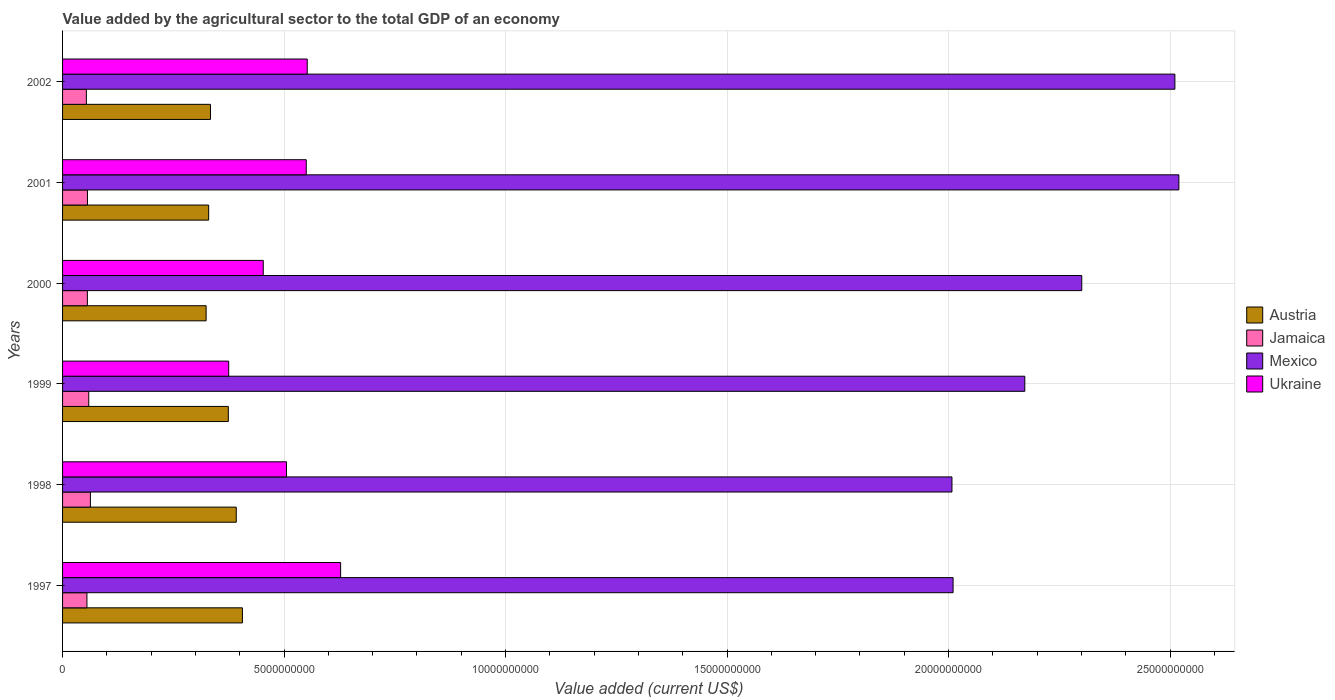How many different coloured bars are there?
Your answer should be compact. 4. How many groups of bars are there?
Your response must be concise. 6. How many bars are there on the 3rd tick from the bottom?
Your answer should be very brief. 4. What is the value added by the agricultural sector to the total GDP in Ukraine in 1997?
Give a very brief answer. 6.28e+09. Across all years, what is the maximum value added by the agricultural sector to the total GDP in Jamaica?
Give a very brief answer. 6.28e+08. Across all years, what is the minimum value added by the agricultural sector to the total GDP in Ukraine?
Keep it short and to the point. 3.75e+09. In which year was the value added by the agricultural sector to the total GDP in Jamaica minimum?
Your answer should be compact. 2002. What is the total value added by the agricultural sector to the total GDP in Jamaica in the graph?
Your response must be concise. 3.43e+09. What is the difference between the value added by the agricultural sector to the total GDP in Jamaica in 1999 and that in 2000?
Your response must be concise. 3.12e+07. What is the difference between the value added by the agricultural sector to the total GDP in Austria in 1999 and the value added by the agricultural sector to the total GDP in Jamaica in 2002?
Offer a very short reply. 3.20e+09. What is the average value added by the agricultural sector to the total GDP in Ukraine per year?
Make the answer very short. 5.11e+09. In the year 2002, what is the difference between the value added by the agricultural sector to the total GDP in Austria and value added by the agricultural sector to the total GDP in Ukraine?
Keep it short and to the point. -2.18e+09. In how many years, is the value added by the agricultural sector to the total GDP in Jamaica greater than 19000000000 US$?
Provide a short and direct response. 0. What is the ratio of the value added by the agricultural sector to the total GDP in Jamaica in 1998 to that in 2002?
Your answer should be compact. 1.17. What is the difference between the highest and the second highest value added by the agricultural sector to the total GDP in Ukraine?
Your answer should be very brief. 7.54e+08. What is the difference between the highest and the lowest value added by the agricultural sector to the total GDP in Ukraine?
Ensure brevity in your answer.  2.53e+09. In how many years, is the value added by the agricultural sector to the total GDP in Mexico greater than the average value added by the agricultural sector to the total GDP in Mexico taken over all years?
Make the answer very short. 3. What does the 3rd bar from the top in 2002 represents?
Provide a short and direct response. Jamaica. What does the 4th bar from the bottom in 1997 represents?
Your response must be concise. Ukraine. How many bars are there?
Provide a short and direct response. 24. Are the values on the major ticks of X-axis written in scientific E-notation?
Provide a succinct answer. No. Where does the legend appear in the graph?
Ensure brevity in your answer.  Center right. What is the title of the graph?
Keep it short and to the point. Value added by the agricultural sector to the total GDP of an economy. What is the label or title of the X-axis?
Make the answer very short. Value added (current US$). What is the Value added (current US$) of Austria in 1997?
Offer a very short reply. 4.06e+09. What is the Value added (current US$) of Jamaica in 1997?
Provide a short and direct response. 5.50e+08. What is the Value added (current US$) of Mexico in 1997?
Ensure brevity in your answer.  2.01e+1. What is the Value added (current US$) in Ukraine in 1997?
Your answer should be compact. 6.28e+09. What is the Value added (current US$) in Austria in 1998?
Your answer should be compact. 3.92e+09. What is the Value added (current US$) in Jamaica in 1998?
Your answer should be very brief. 6.28e+08. What is the Value added (current US$) of Mexico in 1998?
Offer a very short reply. 2.01e+1. What is the Value added (current US$) in Ukraine in 1998?
Offer a very short reply. 5.05e+09. What is the Value added (current US$) of Austria in 1999?
Offer a terse response. 3.74e+09. What is the Value added (current US$) of Jamaica in 1999?
Provide a succinct answer. 5.91e+08. What is the Value added (current US$) of Mexico in 1999?
Ensure brevity in your answer.  2.17e+1. What is the Value added (current US$) in Ukraine in 1999?
Ensure brevity in your answer.  3.75e+09. What is the Value added (current US$) in Austria in 2000?
Provide a short and direct response. 3.24e+09. What is the Value added (current US$) of Jamaica in 2000?
Provide a short and direct response. 5.60e+08. What is the Value added (current US$) in Mexico in 2000?
Your answer should be compact. 2.30e+1. What is the Value added (current US$) in Ukraine in 2000?
Offer a very short reply. 4.53e+09. What is the Value added (current US$) in Austria in 2001?
Offer a terse response. 3.30e+09. What is the Value added (current US$) of Jamaica in 2001?
Provide a succinct answer. 5.62e+08. What is the Value added (current US$) in Mexico in 2001?
Make the answer very short. 2.52e+1. What is the Value added (current US$) in Ukraine in 2001?
Give a very brief answer. 5.50e+09. What is the Value added (current US$) of Austria in 2002?
Keep it short and to the point. 3.34e+09. What is the Value added (current US$) in Jamaica in 2002?
Your answer should be very brief. 5.37e+08. What is the Value added (current US$) in Mexico in 2002?
Your answer should be compact. 2.51e+1. What is the Value added (current US$) in Ukraine in 2002?
Your answer should be very brief. 5.52e+09. Across all years, what is the maximum Value added (current US$) in Austria?
Provide a short and direct response. 4.06e+09. Across all years, what is the maximum Value added (current US$) of Jamaica?
Your answer should be very brief. 6.28e+08. Across all years, what is the maximum Value added (current US$) in Mexico?
Your answer should be compact. 2.52e+1. Across all years, what is the maximum Value added (current US$) in Ukraine?
Give a very brief answer. 6.28e+09. Across all years, what is the minimum Value added (current US$) in Austria?
Your answer should be very brief. 3.24e+09. Across all years, what is the minimum Value added (current US$) of Jamaica?
Ensure brevity in your answer.  5.37e+08. Across all years, what is the minimum Value added (current US$) of Mexico?
Provide a succinct answer. 2.01e+1. Across all years, what is the minimum Value added (current US$) of Ukraine?
Your response must be concise. 3.75e+09. What is the total Value added (current US$) in Austria in the graph?
Offer a very short reply. 2.16e+1. What is the total Value added (current US$) of Jamaica in the graph?
Offer a terse response. 3.43e+09. What is the total Value added (current US$) in Mexico in the graph?
Keep it short and to the point. 1.35e+11. What is the total Value added (current US$) of Ukraine in the graph?
Give a very brief answer. 3.06e+1. What is the difference between the Value added (current US$) in Austria in 1997 and that in 1998?
Ensure brevity in your answer.  1.39e+08. What is the difference between the Value added (current US$) in Jamaica in 1997 and that in 1998?
Give a very brief answer. -7.83e+07. What is the difference between the Value added (current US$) in Mexico in 1997 and that in 1998?
Make the answer very short. 2.55e+07. What is the difference between the Value added (current US$) in Ukraine in 1997 and that in 1998?
Your answer should be very brief. 1.22e+09. What is the difference between the Value added (current US$) of Austria in 1997 and that in 1999?
Give a very brief answer. 3.18e+08. What is the difference between the Value added (current US$) in Jamaica in 1997 and that in 1999?
Give a very brief answer. -4.11e+07. What is the difference between the Value added (current US$) in Mexico in 1997 and that in 1999?
Keep it short and to the point. -1.62e+09. What is the difference between the Value added (current US$) of Ukraine in 1997 and that in 1999?
Your response must be concise. 2.53e+09. What is the difference between the Value added (current US$) in Austria in 1997 and that in 2000?
Your answer should be compact. 8.19e+08. What is the difference between the Value added (current US$) of Jamaica in 1997 and that in 2000?
Provide a succinct answer. -9.88e+06. What is the difference between the Value added (current US$) in Mexico in 1997 and that in 2000?
Provide a short and direct response. -2.90e+09. What is the difference between the Value added (current US$) in Ukraine in 1997 and that in 2000?
Your response must be concise. 1.75e+09. What is the difference between the Value added (current US$) of Austria in 1997 and that in 2001?
Offer a terse response. 7.62e+08. What is the difference between the Value added (current US$) of Jamaica in 1997 and that in 2001?
Your response must be concise. -1.16e+07. What is the difference between the Value added (current US$) in Mexico in 1997 and that in 2001?
Ensure brevity in your answer.  -5.10e+09. What is the difference between the Value added (current US$) of Ukraine in 1997 and that in 2001?
Give a very brief answer. 7.76e+08. What is the difference between the Value added (current US$) in Austria in 1997 and that in 2002?
Provide a short and direct response. 7.21e+08. What is the difference between the Value added (current US$) in Jamaica in 1997 and that in 2002?
Your response must be concise. 1.27e+07. What is the difference between the Value added (current US$) in Mexico in 1997 and that in 2002?
Make the answer very short. -5.01e+09. What is the difference between the Value added (current US$) in Ukraine in 1997 and that in 2002?
Keep it short and to the point. 7.54e+08. What is the difference between the Value added (current US$) in Austria in 1998 and that in 1999?
Ensure brevity in your answer.  1.79e+08. What is the difference between the Value added (current US$) in Jamaica in 1998 and that in 1999?
Provide a short and direct response. 3.72e+07. What is the difference between the Value added (current US$) in Mexico in 1998 and that in 1999?
Make the answer very short. -1.64e+09. What is the difference between the Value added (current US$) in Ukraine in 1998 and that in 1999?
Ensure brevity in your answer.  1.30e+09. What is the difference between the Value added (current US$) of Austria in 1998 and that in 2000?
Ensure brevity in your answer.  6.80e+08. What is the difference between the Value added (current US$) of Jamaica in 1998 and that in 2000?
Your response must be concise. 6.84e+07. What is the difference between the Value added (current US$) of Mexico in 1998 and that in 2000?
Give a very brief answer. -2.93e+09. What is the difference between the Value added (current US$) in Ukraine in 1998 and that in 2000?
Your answer should be compact. 5.25e+08. What is the difference between the Value added (current US$) of Austria in 1998 and that in 2001?
Ensure brevity in your answer.  6.22e+08. What is the difference between the Value added (current US$) in Jamaica in 1998 and that in 2001?
Offer a terse response. 6.67e+07. What is the difference between the Value added (current US$) of Mexico in 1998 and that in 2001?
Make the answer very short. -5.12e+09. What is the difference between the Value added (current US$) in Ukraine in 1998 and that in 2001?
Provide a short and direct response. -4.46e+08. What is the difference between the Value added (current US$) in Austria in 1998 and that in 2002?
Keep it short and to the point. 5.81e+08. What is the difference between the Value added (current US$) of Jamaica in 1998 and that in 2002?
Your response must be concise. 9.09e+07. What is the difference between the Value added (current US$) of Mexico in 1998 and that in 2002?
Provide a succinct answer. -5.03e+09. What is the difference between the Value added (current US$) in Ukraine in 1998 and that in 2002?
Keep it short and to the point. -4.68e+08. What is the difference between the Value added (current US$) of Austria in 1999 and that in 2000?
Offer a terse response. 5.01e+08. What is the difference between the Value added (current US$) in Jamaica in 1999 and that in 2000?
Provide a succinct answer. 3.12e+07. What is the difference between the Value added (current US$) in Mexico in 1999 and that in 2000?
Your response must be concise. -1.29e+09. What is the difference between the Value added (current US$) in Ukraine in 1999 and that in 2000?
Give a very brief answer. -7.80e+08. What is the difference between the Value added (current US$) of Austria in 1999 and that in 2001?
Your answer should be compact. 4.44e+08. What is the difference between the Value added (current US$) of Jamaica in 1999 and that in 2001?
Give a very brief answer. 2.95e+07. What is the difference between the Value added (current US$) of Mexico in 1999 and that in 2001?
Provide a short and direct response. -3.48e+09. What is the difference between the Value added (current US$) of Ukraine in 1999 and that in 2001?
Provide a succinct answer. -1.75e+09. What is the difference between the Value added (current US$) of Austria in 1999 and that in 2002?
Keep it short and to the point. 4.03e+08. What is the difference between the Value added (current US$) in Jamaica in 1999 and that in 2002?
Offer a terse response. 5.38e+07. What is the difference between the Value added (current US$) of Mexico in 1999 and that in 2002?
Ensure brevity in your answer.  -3.39e+09. What is the difference between the Value added (current US$) of Ukraine in 1999 and that in 2002?
Your answer should be very brief. -1.77e+09. What is the difference between the Value added (current US$) of Austria in 2000 and that in 2001?
Provide a short and direct response. -5.76e+07. What is the difference between the Value added (current US$) in Jamaica in 2000 and that in 2001?
Provide a short and direct response. -1.73e+06. What is the difference between the Value added (current US$) of Mexico in 2000 and that in 2001?
Ensure brevity in your answer.  -2.19e+09. What is the difference between the Value added (current US$) in Ukraine in 2000 and that in 2001?
Offer a very short reply. -9.71e+08. What is the difference between the Value added (current US$) of Austria in 2000 and that in 2002?
Provide a succinct answer. -9.85e+07. What is the difference between the Value added (current US$) of Jamaica in 2000 and that in 2002?
Your answer should be compact. 2.26e+07. What is the difference between the Value added (current US$) in Mexico in 2000 and that in 2002?
Your answer should be very brief. -2.10e+09. What is the difference between the Value added (current US$) of Ukraine in 2000 and that in 2002?
Give a very brief answer. -9.93e+08. What is the difference between the Value added (current US$) in Austria in 2001 and that in 2002?
Offer a terse response. -4.09e+07. What is the difference between the Value added (current US$) of Jamaica in 2001 and that in 2002?
Ensure brevity in your answer.  2.43e+07. What is the difference between the Value added (current US$) of Mexico in 2001 and that in 2002?
Your response must be concise. 9.01e+07. What is the difference between the Value added (current US$) of Ukraine in 2001 and that in 2002?
Offer a very short reply. -2.22e+07. What is the difference between the Value added (current US$) of Austria in 1997 and the Value added (current US$) of Jamaica in 1998?
Your answer should be compact. 3.43e+09. What is the difference between the Value added (current US$) of Austria in 1997 and the Value added (current US$) of Mexico in 1998?
Give a very brief answer. -1.60e+1. What is the difference between the Value added (current US$) in Austria in 1997 and the Value added (current US$) in Ukraine in 1998?
Ensure brevity in your answer.  -9.95e+08. What is the difference between the Value added (current US$) in Jamaica in 1997 and the Value added (current US$) in Mexico in 1998?
Your answer should be compact. -1.95e+1. What is the difference between the Value added (current US$) of Jamaica in 1997 and the Value added (current US$) of Ukraine in 1998?
Give a very brief answer. -4.50e+09. What is the difference between the Value added (current US$) of Mexico in 1997 and the Value added (current US$) of Ukraine in 1998?
Offer a very short reply. 1.50e+1. What is the difference between the Value added (current US$) in Austria in 1997 and the Value added (current US$) in Jamaica in 1999?
Give a very brief answer. 3.47e+09. What is the difference between the Value added (current US$) in Austria in 1997 and the Value added (current US$) in Mexico in 1999?
Ensure brevity in your answer.  -1.77e+1. What is the difference between the Value added (current US$) in Austria in 1997 and the Value added (current US$) in Ukraine in 1999?
Provide a succinct answer. 3.10e+08. What is the difference between the Value added (current US$) in Jamaica in 1997 and the Value added (current US$) in Mexico in 1999?
Your answer should be compact. -2.12e+1. What is the difference between the Value added (current US$) in Jamaica in 1997 and the Value added (current US$) in Ukraine in 1999?
Provide a short and direct response. -3.20e+09. What is the difference between the Value added (current US$) of Mexico in 1997 and the Value added (current US$) of Ukraine in 1999?
Your response must be concise. 1.64e+1. What is the difference between the Value added (current US$) in Austria in 1997 and the Value added (current US$) in Jamaica in 2000?
Offer a terse response. 3.50e+09. What is the difference between the Value added (current US$) of Austria in 1997 and the Value added (current US$) of Mexico in 2000?
Your response must be concise. -1.89e+1. What is the difference between the Value added (current US$) in Austria in 1997 and the Value added (current US$) in Ukraine in 2000?
Make the answer very short. -4.70e+08. What is the difference between the Value added (current US$) of Jamaica in 1997 and the Value added (current US$) of Mexico in 2000?
Give a very brief answer. -2.25e+1. What is the difference between the Value added (current US$) of Jamaica in 1997 and the Value added (current US$) of Ukraine in 2000?
Your response must be concise. -3.98e+09. What is the difference between the Value added (current US$) in Mexico in 1997 and the Value added (current US$) in Ukraine in 2000?
Keep it short and to the point. 1.56e+1. What is the difference between the Value added (current US$) in Austria in 1997 and the Value added (current US$) in Jamaica in 2001?
Your answer should be compact. 3.50e+09. What is the difference between the Value added (current US$) of Austria in 1997 and the Value added (current US$) of Mexico in 2001?
Your answer should be very brief. -2.11e+1. What is the difference between the Value added (current US$) of Austria in 1997 and the Value added (current US$) of Ukraine in 2001?
Offer a very short reply. -1.44e+09. What is the difference between the Value added (current US$) in Jamaica in 1997 and the Value added (current US$) in Mexico in 2001?
Your answer should be very brief. -2.46e+1. What is the difference between the Value added (current US$) of Jamaica in 1997 and the Value added (current US$) of Ukraine in 2001?
Your response must be concise. -4.95e+09. What is the difference between the Value added (current US$) in Mexico in 1997 and the Value added (current US$) in Ukraine in 2001?
Your answer should be compact. 1.46e+1. What is the difference between the Value added (current US$) of Austria in 1997 and the Value added (current US$) of Jamaica in 2002?
Provide a succinct answer. 3.52e+09. What is the difference between the Value added (current US$) in Austria in 1997 and the Value added (current US$) in Mexico in 2002?
Give a very brief answer. -2.10e+1. What is the difference between the Value added (current US$) of Austria in 1997 and the Value added (current US$) of Ukraine in 2002?
Your answer should be compact. -1.46e+09. What is the difference between the Value added (current US$) in Jamaica in 1997 and the Value added (current US$) in Mexico in 2002?
Provide a succinct answer. -2.46e+1. What is the difference between the Value added (current US$) in Jamaica in 1997 and the Value added (current US$) in Ukraine in 2002?
Your response must be concise. -4.97e+09. What is the difference between the Value added (current US$) in Mexico in 1997 and the Value added (current US$) in Ukraine in 2002?
Keep it short and to the point. 1.46e+1. What is the difference between the Value added (current US$) in Austria in 1998 and the Value added (current US$) in Jamaica in 1999?
Ensure brevity in your answer.  3.33e+09. What is the difference between the Value added (current US$) in Austria in 1998 and the Value added (current US$) in Mexico in 1999?
Keep it short and to the point. -1.78e+1. What is the difference between the Value added (current US$) in Austria in 1998 and the Value added (current US$) in Ukraine in 1999?
Your answer should be very brief. 1.70e+08. What is the difference between the Value added (current US$) of Jamaica in 1998 and the Value added (current US$) of Mexico in 1999?
Offer a terse response. -2.11e+1. What is the difference between the Value added (current US$) in Jamaica in 1998 and the Value added (current US$) in Ukraine in 1999?
Give a very brief answer. -3.12e+09. What is the difference between the Value added (current US$) of Mexico in 1998 and the Value added (current US$) of Ukraine in 1999?
Offer a terse response. 1.63e+1. What is the difference between the Value added (current US$) in Austria in 1998 and the Value added (current US$) in Jamaica in 2000?
Your answer should be very brief. 3.36e+09. What is the difference between the Value added (current US$) of Austria in 1998 and the Value added (current US$) of Mexico in 2000?
Give a very brief answer. -1.91e+1. What is the difference between the Value added (current US$) of Austria in 1998 and the Value added (current US$) of Ukraine in 2000?
Provide a succinct answer. -6.09e+08. What is the difference between the Value added (current US$) of Jamaica in 1998 and the Value added (current US$) of Mexico in 2000?
Ensure brevity in your answer.  -2.24e+1. What is the difference between the Value added (current US$) in Jamaica in 1998 and the Value added (current US$) in Ukraine in 2000?
Provide a succinct answer. -3.90e+09. What is the difference between the Value added (current US$) in Mexico in 1998 and the Value added (current US$) in Ukraine in 2000?
Your answer should be very brief. 1.55e+1. What is the difference between the Value added (current US$) of Austria in 1998 and the Value added (current US$) of Jamaica in 2001?
Keep it short and to the point. 3.36e+09. What is the difference between the Value added (current US$) in Austria in 1998 and the Value added (current US$) in Mexico in 2001?
Your answer should be compact. -2.13e+1. What is the difference between the Value added (current US$) of Austria in 1998 and the Value added (current US$) of Ukraine in 2001?
Offer a terse response. -1.58e+09. What is the difference between the Value added (current US$) of Jamaica in 1998 and the Value added (current US$) of Mexico in 2001?
Ensure brevity in your answer.  -2.46e+1. What is the difference between the Value added (current US$) of Jamaica in 1998 and the Value added (current US$) of Ukraine in 2001?
Make the answer very short. -4.87e+09. What is the difference between the Value added (current US$) in Mexico in 1998 and the Value added (current US$) in Ukraine in 2001?
Keep it short and to the point. 1.46e+1. What is the difference between the Value added (current US$) of Austria in 1998 and the Value added (current US$) of Jamaica in 2002?
Provide a succinct answer. 3.38e+09. What is the difference between the Value added (current US$) of Austria in 1998 and the Value added (current US$) of Mexico in 2002?
Offer a very short reply. -2.12e+1. What is the difference between the Value added (current US$) in Austria in 1998 and the Value added (current US$) in Ukraine in 2002?
Offer a terse response. -1.60e+09. What is the difference between the Value added (current US$) in Jamaica in 1998 and the Value added (current US$) in Mexico in 2002?
Make the answer very short. -2.45e+1. What is the difference between the Value added (current US$) in Jamaica in 1998 and the Value added (current US$) in Ukraine in 2002?
Offer a very short reply. -4.89e+09. What is the difference between the Value added (current US$) in Mexico in 1998 and the Value added (current US$) in Ukraine in 2002?
Offer a terse response. 1.46e+1. What is the difference between the Value added (current US$) of Austria in 1999 and the Value added (current US$) of Jamaica in 2000?
Provide a short and direct response. 3.18e+09. What is the difference between the Value added (current US$) of Austria in 1999 and the Value added (current US$) of Mexico in 2000?
Give a very brief answer. -1.93e+1. What is the difference between the Value added (current US$) of Austria in 1999 and the Value added (current US$) of Ukraine in 2000?
Keep it short and to the point. -7.88e+08. What is the difference between the Value added (current US$) of Jamaica in 1999 and the Value added (current US$) of Mexico in 2000?
Offer a very short reply. -2.24e+1. What is the difference between the Value added (current US$) in Jamaica in 1999 and the Value added (current US$) in Ukraine in 2000?
Provide a succinct answer. -3.94e+09. What is the difference between the Value added (current US$) in Mexico in 1999 and the Value added (current US$) in Ukraine in 2000?
Your answer should be very brief. 1.72e+1. What is the difference between the Value added (current US$) in Austria in 1999 and the Value added (current US$) in Jamaica in 2001?
Ensure brevity in your answer.  3.18e+09. What is the difference between the Value added (current US$) of Austria in 1999 and the Value added (current US$) of Mexico in 2001?
Offer a terse response. -2.15e+1. What is the difference between the Value added (current US$) of Austria in 1999 and the Value added (current US$) of Ukraine in 2001?
Your answer should be very brief. -1.76e+09. What is the difference between the Value added (current US$) in Jamaica in 1999 and the Value added (current US$) in Mexico in 2001?
Provide a short and direct response. -2.46e+1. What is the difference between the Value added (current US$) in Jamaica in 1999 and the Value added (current US$) in Ukraine in 2001?
Make the answer very short. -4.91e+09. What is the difference between the Value added (current US$) in Mexico in 1999 and the Value added (current US$) in Ukraine in 2001?
Provide a short and direct response. 1.62e+1. What is the difference between the Value added (current US$) of Austria in 1999 and the Value added (current US$) of Jamaica in 2002?
Provide a succinct answer. 3.20e+09. What is the difference between the Value added (current US$) in Austria in 1999 and the Value added (current US$) in Mexico in 2002?
Your answer should be compact. -2.14e+1. What is the difference between the Value added (current US$) of Austria in 1999 and the Value added (current US$) of Ukraine in 2002?
Give a very brief answer. -1.78e+09. What is the difference between the Value added (current US$) in Jamaica in 1999 and the Value added (current US$) in Mexico in 2002?
Your answer should be compact. -2.45e+1. What is the difference between the Value added (current US$) in Jamaica in 1999 and the Value added (current US$) in Ukraine in 2002?
Provide a short and direct response. -4.93e+09. What is the difference between the Value added (current US$) of Mexico in 1999 and the Value added (current US$) of Ukraine in 2002?
Give a very brief answer. 1.62e+1. What is the difference between the Value added (current US$) of Austria in 2000 and the Value added (current US$) of Jamaica in 2001?
Ensure brevity in your answer.  2.68e+09. What is the difference between the Value added (current US$) in Austria in 2000 and the Value added (current US$) in Mexico in 2001?
Your response must be concise. -2.20e+1. What is the difference between the Value added (current US$) in Austria in 2000 and the Value added (current US$) in Ukraine in 2001?
Keep it short and to the point. -2.26e+09. What is the difference between the Value added (current US$) in Jamaica in 2000 and the Value added (current US$) in Mexico in 2001?
Give a very brief answer. -2.46e+1. What is the difference between the Value added (current US$) in Jamaica in 2000 and the Value added (current US$) in Ukraine in 2001?
Keep it short and to the point. -4.94e+09. What is the difference between the Value added (current US$) of Mexico in 2000 and the Value added (current US$) of Ukraine in 2001?
Provide a succinct answer. 1.75e+1. What is the difference between the Value added (current US$) of Austria in 2000 and the Value added (current US$) of Jamaica in 2002?
Give a very brief answer. 2.70e+09. What is the difference between the Value added (current US$) of Austria in 2000 and the Value added (current US$) of Mexico in 2002?
Keep it short and to the point. -2.19e+1. What is the difference between the Value added (current US$) in Austria in 2000 and the Value added (current US$) in Ukraine in 2002?
Offer a very short reply. -2.28e+09. What is the difference between the Value added (current US$) in Jamaica in 2000 and the Value added (current US$) in Mexico in 2002?
Your answer should be compact. -2.45e+1. What is the difference between the Value added (current US$) in Jamaica in 2000 and the Value added (current US$) in Ukraine in 2002?
Provide a short and direct response. -4.96e+09. What is the difference between the Value added (current US$) of Mexico in 2000 and the Value added (current US$) of Ukraine in 2002?
Keep it short and to the point. 1.75e+1. What is the difference between the Value added (current US$) of Austria in 2001 and the Value added (current US$) of Jamaica in 2002?
Provide a succinct answer. 2.76e+09. What is the difference between the Value added (current US$) of Austria in 2001 and the Value added (current US$) of Mexico in 2002?
Your answer should be very brief. -2.18e+1. What is the difference between the Value added (current US$) in Austria in 2001 and the Value added (current US$) in Ukraine in 2002?
Provide a succinct answer. -2.22e+09. What is the difference between the Value added (current US$) in Jamaica in 2001 and the Value added (current US$) in Mexico in 2002?
Offer a terse response. -2.45e+1. What is the difference between the Value added (current US$) in Jamaica in 2001 and the Value added (current US$) in Ukraine in 2002?
Offer a terse response. -4.96e+09. What is the difference between the Value added (current US$) in Mexico in 2001 and the Value added (current US$) in Ukraine in 2002?
Your answer should be very brief. 1.97e+1. What is the average Value added (current US$) of Austria per year?
Your answer should be very brief. 3.60e+09. What is the average Value added (current US$) in Jamaica per year?
Your response must be concise. 5.72e+08. What is the average Value added (current US$) of Mexico per year?
Your answer should be very brief. 2.25e+1. What is the average Value added (current US$) of Ukraine per year?
Provide a succinct answer. 5.11e+09. In the year 1997, what is the difference between the Value added (current US$) of Austria and Value added (current US$) of Jamaica?
Give a very brief answer. 3.51e+09. In the year 1997, what is the difference between the Value added (current US$) in Austria and Value added (current US$) in Mexico?
Ensure brevity in your answer.  -1.60e+1. In the year 1997, what is the difference between the Value added (current US$) of Austria and Value added (current US$) of Ukraine?
Provide a short and direct response. -2.22e+09. In the year 1997, what is the difference between the Value added (current US$) of Jamaica and Value added (current US$) of Mexico?
Provide a succinct answer. -1.96e+1. In the year 1997, what is the difference between the Value added (current US$) in Jamaica and Value added (current US$) in Ukraine?
Your answer should be compact. -5.73e+09. In the year 1997, what is the difference between the Value added (current US$) of Mexico and Value added (current US$) of Ukraine?
Offer a very short reply. 1.38e+1. In the year 1998, what is the difference between the Value added (current US$) in Austria and Value added (current US$) in Jamaica?
Provide a short and direct response. 3.29e+09. In the year 1998, what is the difference between the Value added (current US$) of Austria and Value added (current US$) of Mexico?
Ensure brevity in your answer.  -1.62e+1. In the year 1998, what is the difference between the Value added (current US$) in Austria and Value added (current US$) in Ukraine?
Provide a short and direct response. -1.13e+09. In the year 1998, what is the difference between the Value added (current US$) of Jamaica and Value added (current US$) of Mexico?
Keep it short and to the point. -1.94e+1. In the year 1998, what is the difference between the Value added (current US$) of Jamaica and Value added (current US$) of Ukraine?
Provide a succinct answer. -4.43e+09. In the year 1998, what is the difference between the Value added (current US$) of Mexico and Value added (current US$) of Ukraine?
Your answer should be compact. 1.50e+1. In the year 1999, what is the difference between the Value added (current US$) of Austria and Value added (current US$) of Jamaica?
Your answer should be compact. 3.15e+09. In the year 1999, what is the difference between the Value added (current US$) in Austria and Value added (current US$) in Mexico?
Ensure brevity in your answer.  -1.80e+1. In the year 1999, what is the difference between the Value added (current US$) of Austria and Value added (current US$) of Ukraine?
Your response must be concise. -8.55e+06. In the year 1999, what is the difference between the Value added (current US$) in Jamaica and Value added (current US$) in Mexico?
Ensure brevity in your answer.  -2.11e+1. In the year 1999, what is the difference between the Value added (current US$) in Jamaica and Value added (current US$) in Ukraine?
Offer a very short reply. -3.16e+09. In the year 1999, what is the difference between the Value added (current US$) of Mexico and Value added (current US$) of Ukraine?
Offer a very short reply. 1.80e+1. In the year 2000, what is the difference between the Value added (current US$) of Austria and Value added (current US$) of Jamaica?
Provide a short and direct response. 2.68e+09. In the year 2000, what is the difference between the Value added (current US$) in Austria and Value added (current US$) in Mexico?
Make the answer very short. -1.98e+1. In the year 2000, what is the difference between the Value added (current US$) of Austria and Value added (current US$) of Ukraine?
Your response must be concise. -1.29e+09. In the year 2000, what is the difference between the Value added (current US$) of Jamaica and Value added (current US$) of Mexico?
Keep it short and to the point. -2.24e+1. In the year 2000, what is the difference between the Value added (current US$) of Jamaica and Value added (current US$) of Ukraine?
Provide a short and direct response. -3.97e+09. In the year 2000, what is the difference between the Value added (current US$) of Mexico and Value added (current US$) of Ukraine?
Keep it short and to the point. 1.85e+1. In the year 2001, what is the difference between the Value added (current US$) in Austria and Value added (current US$) in Jamaica?
Ensure brevity in your answer.  2.74e+09. In the year 2001, what is the difference between the Value added (current US$) of Austria and Value added (current US$) of Mexico?
Make the answer very short. -2.19e+1. In the year 2001, what is the difference between the Value added (current US$) of Austria and Value added (current US$) of Ukraine?
Offer a very short reply. -2.20e+09. In the year 2001, what is the difference between the Value added (current US$) in Jamaica and Value added (current US$) in Mexico?
Ensure brevity in your answer.  -2.46e+1. In the year 2001, what is the difference between the Value added (current US$) in Jamaica and Value added (current US$) in Ukraine?
Your response must be concise. -4.94e+09. In the year 2001, what is the difference between the Value added (current US$) in Mexico and Value added (current US$) in Ukraine?
Make the answer very short. 1.97e+1. In the year 2002, what is the difference between the Value added (current US$) of Austria and Value added (current US$) of Jamaica?
Give a very brief answer. 2.80e+09. In the year 2002, what is the difference between the Value added (current US$) in Austria and Value added (current US$) in Mexico?
Offer a terse response. -2.18e+1. In the year 2002, what is the difference between the Value added (current US$) in Austria and Value added (current US$) in Ukraine?
Your answer should be very brief. -2.18e+09. In the year 2002, what is the difference between the Value added (current US$) of Jamaica and Value added (current US$) of Mexico?
Provide a short and direct response. -2.46e+1. In the year 2002, what is the difference between the Value added (current US$) of Jamaica and Value added (current US$) of Ukraine?
Provide a short and direct response. -4.99e+09. In the year 2002, what is the difference between the Value added (current US$) in Mexico and Value added (current US$) in Ukraine?
Keep it short and to the point. 1.96e+1. What is the ratio of the Value added (current US$) of Austria in 1997 to that in 1998?
Offer a very short reply. 1.04. What is the ratio of the Value added (current US$) of Jamaica in 1997 to that in 1998?
Offer a terse response. 0.88. What is the ratio of the Value added (current US$) in Ukraine in 1997 to that in 1998?
Provide a succinct answer. 1.24. What is the ratio of the Value added (current US$) in Austria in 1997 to that in 1999?
Provide a short and direct response. 1.09. What is the ratio of the Value added (current US$) of Jamaica in 1997 to that in 1999?
Offer a terse response. 0.93. What is the ratio of the Value added (current US$) in Mexico in 1997 to that in 1999?
Offer a terse response. 0.93. What is the ratio of the Value added (current US$) in Ukraine in 1997 to that in 1999?
Your answer should be compact. 1.67. What is the ratio of the Value added (current US$) in Austria in 1997 to that in 2000?
Give a very brief answer. 1.25. What is the ratio of the Value added (current US$) of Jamaica in 1997 to that in 2000?
Provide a short and direct response. 0.98. What is the ratio of the Value added (current US$) in Mexico in 1997 to that in 2000?
Offer a terse response. 0.87. What is the ratio of the Value added (current US$) of Ukraine in 1997 to that in 2000?
Your answer should be compact. 1.39. What is the ratio of the Value added (current US$) in Austria in 1997 to that in 2001?
Provide a short and direct response. 1.23. What is the ratio of the Value added (current US$) of Jamaica in 1997 to that in 2001?
Provide a short and direct response. 0.98. What is the ratio of the Value added (current US$) in Mexico in 1997 to that in 2001?
Offer a terse response. 0.8. What is the ratio of the Value added (current US$) of Ukraine in 1997 to that in 2001?
Give a very brief answer. 1.14. What is the ratio of the Value added (current US$) in Austria in 1997 to that in 2002?
Make the answer very short. 1.22. What is the ratio of the Value added (current US$) in Jamaica in 1997 to that in 2002?
Provide a short and direct response. 1.02. What is the ratio of the Value added (current US$) in Mexico in 1997 to that in 2002?
Your response must be concise. 0.8. What is the ratio of the Value added (current US$) in Ukraine in 1997 to that in 2002?
Keep it short and to the point. 1.14. What is the ratio of the Value added (current US$) in Austria in 1998 to that in 1999?
Provide a succinct answer. 1.05. What is the ratio of the Value added (current US$) in Jamaica in 1998 to that in 1999?
Your response must be concise. 1.06. What is the ratio of the Value added (current US$) of Mexico in 1998 to that in 1999?
Keep it short and to the point. 0.92. What is the ratio of the Value added (current US$) of Ukraine in 1998 to that in 1999?
Your answer should be compact. 1.35. What is the ratio of the Value added (current US$) in Austria in 1998 to that in 2000?
Give a very brief answer. 1.21. What is the ratio of the Value added (current US$) in Jamaica in 1998 to that in 2000?
Provide a succinct answer. 1.12. What is the ratio of the Value added (current US$) in Mexico in 1998 to that in 2000?
Offer a terse response. 0.87. What is the ratio of the Value added (current US$) of Ukraine in 1998 to that in 2000?
Make the answer very short. 1.12. What is the ratio of the Value added (current US$) in Austria in 1998 to that in 2001?
Provide a succinct answer. 1.19. What is the ratio of the Value added (current US$) in Jamaica in 1998 to that in 2001?
Provide a short and direct response. 1.12. What is the ratio of the Value added (current US$) of Mexico in 1998 to that in 2001?
Your answer should be compact. 0.8. What is the ratio of the Value added (current US$) in Ukraine in 1998 to that in 2001?
Ensure brevity in your answer.  0.92. What is the ratio of the Value added (current US$) in Austria in 1998 to that in 2002?
Your answer should be compact. 1.17. What is the ratio of the Value added (current US$) of Jamaica in 1998 to that in 2002?
Offer a terse response. 1.17. What is the ratio of the Value added (current US$) in Mexico in 1998 to that in 2002?
Your answer should be compact. 0.8. What is the ratio of the Value added (current US$) in Ukraine in 1998 to that in 2002?
Keep it short and to the point. 0.92. What is the ratio of the Value added (current US$) in Austria in 1999 to that in 2000?
Offer a very short reply. 1.15. What is the ratio of the Value added (current US$) of Jamaica in 1999 to that in 2000?
Ensure brevity in your answer.  1.06. What is the ratio of the Value added (current US$) in Mexico in 1999 to that in 2000?
Offer a very short reply. 0.94. What is the ratio of the Value added (current US$) in Ukraine in 1999 to that in 2000?
Ensure brevity in your answer.  0.83. What is the ratio of the Value added (current US$) in Austria in 1999 to that in 2001?
Your response must be concise. 1.13. What is the ratio of the Value added (current US$) in Jamaica in 1999 to that in 2001?
Offer a very short reply. 1.05. What is the ratio of the Value added (current US$) of Mexico in 1999 to that in 2001?
Your answer should be very brief. 0.86. What is the ratio of the Value added (current US$) in Ukraine in 1999 to that in 2001?
Your response must be concise. 0.68. What is the ratio of the Value added (current US$) in Austria in 1999 to that in 2002?
Your answer should be compact. 1.12. What is the ratio of the Value added (current US$) of Jamaica in 1999 to that in 2002?
Provide a succinct answer. 1.1. What is the ratio of the Value added (current US$) of Mexico in 1999 to that in 2002?
Your answer should be compact. 0.87. What is the ratio of the Value added (current US$) of Ukraine in 1999 to that in 2002?
Your answer should be compact. 0.68. What is the ratio of the Value added (current US$) in Austria in 2000 to that in 2001?
Keep it short and to the point. 0.98. What is the ratio of the Value added (current US$) of Jamaica in 2000 to that in 2001?
Your answer should be very brief. 1. What is the ratio of the Value added (current US$) of Mexico in 2000 to that in 2001?
Make the answer very short. 0.91. What is the ratio of the Value added (current US$) of Ukraine in 2000 to that in 2001?
Provide a succinct answer. 0.82. What is the ratio of the Value added (current US$) of Austria in 2000 to that in 2002?
Offer a terse response. 0.97. What is the ratio of the Value added (current US$) of Jamaica in 2000 to that in 2002?
Offer a very short reply. 1.04. What is the ratio of the Value added (current US$) of Mexico in 2000 to that in 2002?
Your response must be concise. 0.92. What is the ratio of the Value added (current US$) of Ukraine in 2000 to that in 2002?
Make the answer very short. 0.82. What is the ratio of the Value added (current US$) of Jamaica in 2001 to that in 2002?
Ensure brevity in your answer.  1.05. What is the ratio of the Value added (current US$) of Mexico in 2001 to that in 2002?
Your answer should be compact. 1. What is the ratio of the Value added (current US$) of Ukraine in 2001 to that in 2002?
Your answer should be compact. 1. What is the difference between the highest and the second highest Value added (current US$) in Austria?
Your answer should be compact. 1.39e+08. What is the difference between the highest and the second highest Value added (current US$) in Jamaica?
Provide a succinct answer. 3.72e+07. What is the difference between the highest and the second highest Value added (current US$) of Mexico?
Your answer should be very brief. 9.01e+07. What is the difference between the highest and the second highest Value added (current US$) of Ukraine?
Offer a very short reply. 7.54e+08. What is the difference between the highest and the lowest Value added (current US$) of Austria?
Your answer should be very brief. 8.19e+08. What is the difference between the highest and the lowest Value added (current US$) of Jamaica?
Give a very brief answer. 9.09e+07. What is the difference between the highest and the lowest Value added (current US$) in Mexico?
Your answer should be very brief. 5.12e+09. What is the difference between the highest and the lowest Value added (current US$) in Ukraine?
Make the answer very short. 2.53e+09. 